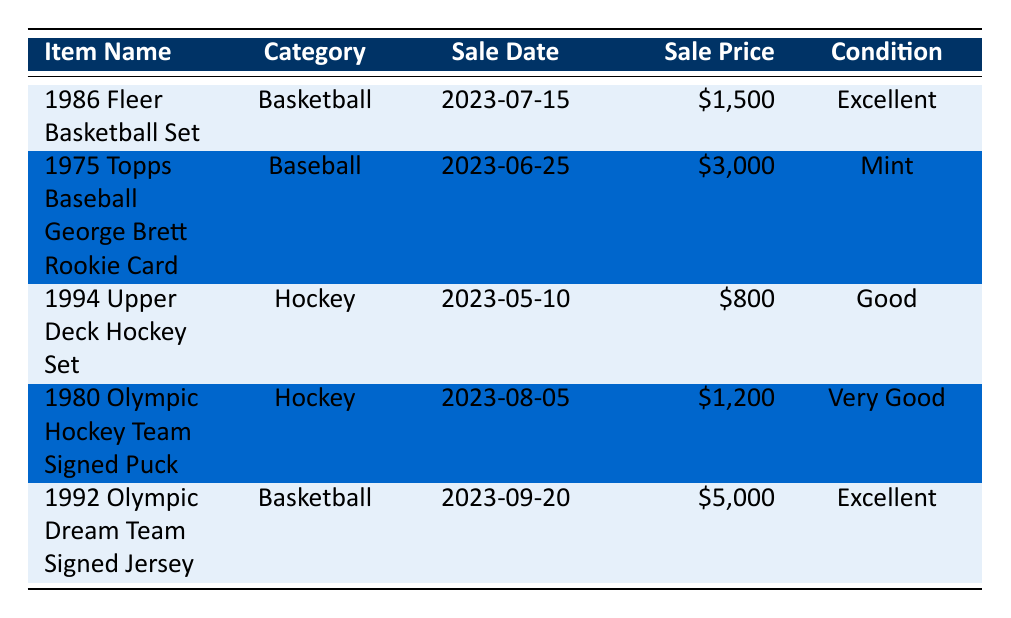What is the sale price of the 1986 Fleer Basketball Set? The table lists the sale price of the 1986 Fleer Basketball Set in the row where its name appears. According to the table, the sale price is $1,500.
Answer: $1,500 Which item sold for the highest price? To find the item that sold for the highest price, we can compare all sale prices listed in the table. The prices are: $1,500, $3,000, $800, $1,200, and $5,000. The highest price is $5,000, corresponding to the 1992 Olympic Dream Team Signed Jersey.
Answer: 1992 Olympic Dream Team Signed Jersey How many items were sold in the month of June? The table contains entries with sale dates, and we look for those that fall in June. Checking the sale dates, there is one item sold on June 25, which is the 1975 Topps Baseball George Brett Rookie Card. Hence, only one item was sold in June.
Answer: 1 What is the average sale price of the items listed in the table? To find the average sale price, we first sum up all the sale prices: $1,500 + $3,000 + $800 + $1,200 + $5,000 = $11,500. There are five items in total, so we divide the total by 5: $11,500 / 5 = $2,300.
Answer: $2,300 Did any item sold in Miami, FL? To answer, we check the location column in the table for any entries that mention Miami, FL. The table shows one item, the 1980 Olympic Hockey Team Signed Puck, was sold in Miami. Thus, the answer is yes.
Answer: Yes 